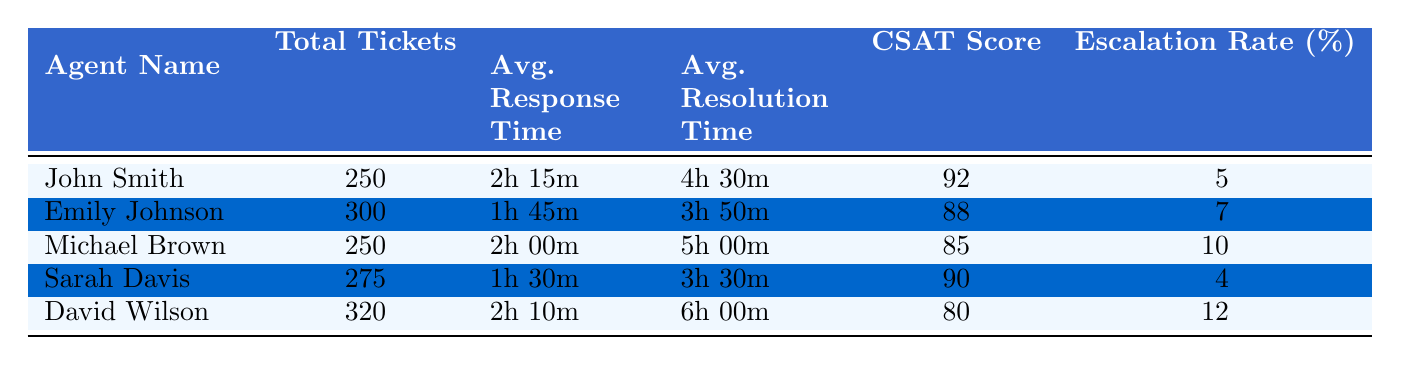What is the highest Customer Satisfaction Score among the agents? The Customer Satisfaction Scores listed are 92, 88, 85, 90, and 80. Among these, 92 is the highest score achieved by John Smith.
Answer: 92 Which agent had the lowest Average Resolution Time? The Average Resolution Times are as follows: 4h 30m (John Smith), 3h 50m (Emily Johnson), 5h 00m (Michael Brown), 3h 30m (Sarah Davis), and 6h 00m (David Wilson). The lowest time is 3h 30m, which belongs to Sarah Davis.
Answer: Sarah Davis What is the average Total Tickets Handled by the agents listed? To find the average, sum the Total Tickets Handled: 250 + 300 + 250 + 275 + 320 = 1395. Then divide by the number of agents (5), giving 1395 / 5 = 279.
Answer: 279 Did any agent have an Escalation Rate greater than 10%? The Escalation Rates are 5, 7, 10, 4, and 12 percent respectively. Since 12 percent (David Wilson) is greater than 10, the answer is yes.
Answer: Yes What is the difference in Average Response Time between the agent with the shortest and the longest response times? The times are: 2h 15m (John Smith), 1h 45m (Emily Johnson), 2h 00m (Michael Brown), 1h 30m (Sarah Davis), and 2h 10m (David Wilson). The shortest is 1h 30m and the longest is 2h 15m. The difference is calculated as follows: 2h 15m - 1h 30m = 45 minutes.
Answer: 45 minutes Which agent handled the most tickets, and what was their Average Response Time? The agents' Total Tickets Handled show that David Wilson handled the most at 320 tickets. His Average Response Time is recorded as 2h 10m.
Answer: David Wilson, 2h 10m Is the Customer Satisfaction Score of Emily Johnson higher than that of Michael Brown? Emily Johnson has a Customer Satisfaction Score of 88, while Michael Brown's Score is 85. Since 88 is greater than 85, the answer is yes.
Answer: Yes What is the sum of the Average Resolution Times for all agents? The Average Resolution Times are 4h 30m, 3h 50m, 5h 00m, 3h 30m, and 6h 00m respectively. First convert these times to minutes: 270 + 230 + 300 + 210 + 360 = 1370 minutes. Now convert back to hours and minutes: 1370 minutes equals 22 hours and 50 minutes.
Answer: 22 hours and 50 minutes 